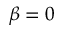Convert formula to latex. <formula><loc_0><loc_0><loc_500><loc_500>\beta = 0</formula> 